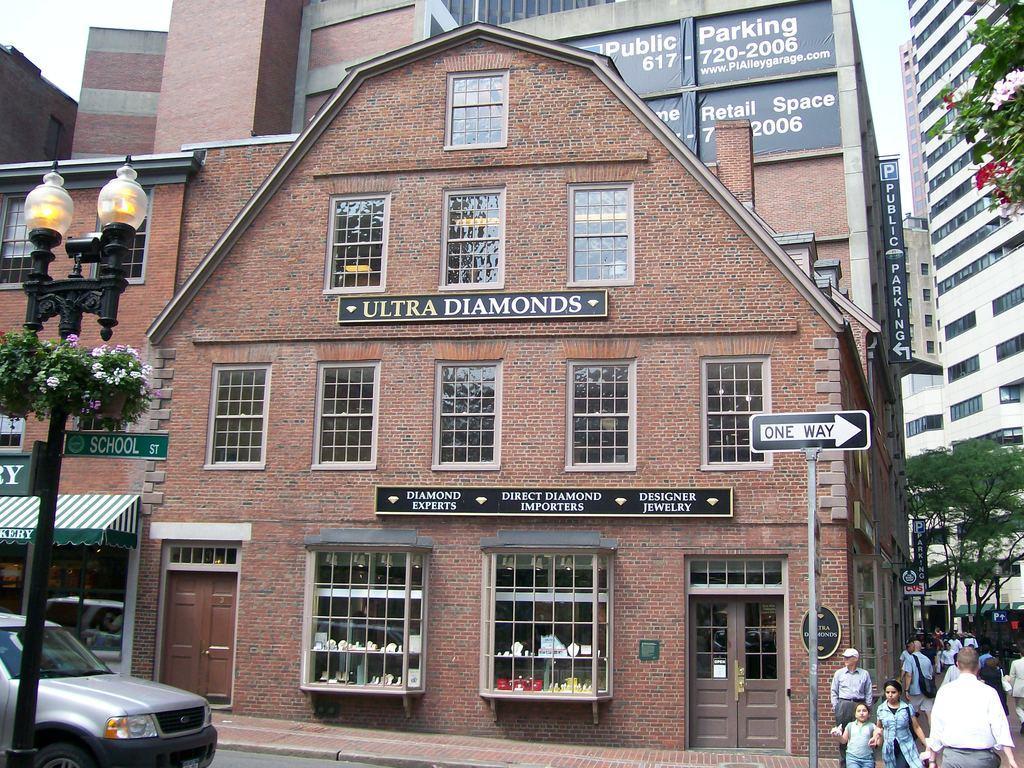Please provide a concise description of this image. In this image we can see so many buildings. In front of the building road is there, on road car is present and people are moving. Left side of the image we can see one black color pole with lights and to the right side of the image one sign board is present and trees are present. 